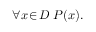<formula> <loc_0><loc_0><loc_500><loc_500>\forall x \, \in \, D \, P ( x ) .</formula> 